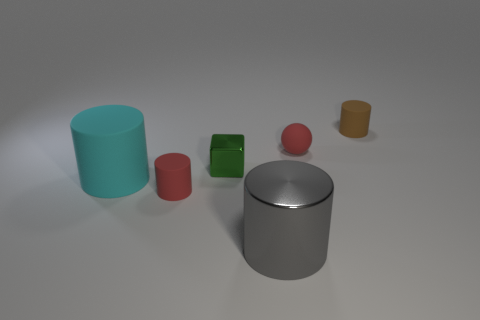Add 1 small green blocks. How many objects exist? 7 Subtract all cylinders. How many objects are left? 2 Add 1 big cyan cylinders. How many big cyan cylinders are left? 2 Add 5 big matte things. How many big matte things exist? 6 Subtract 0 green balls. How many objects are left? 6 Subtract all blocks. Subtract all shiny cubes. How many objects are left? 4 